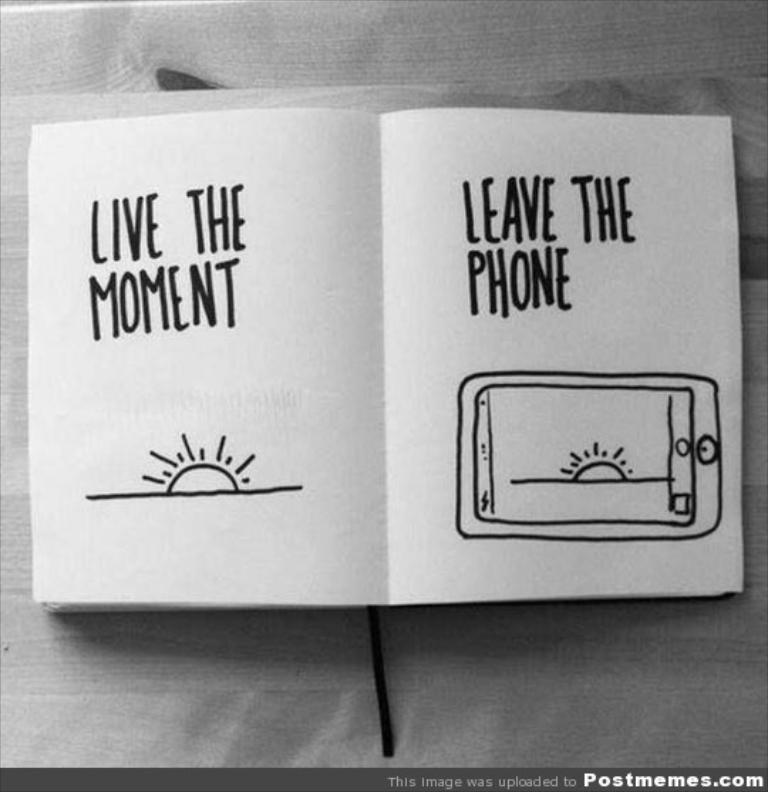What should one do with their phone based on this flyer?
Provide a succinct answer. Unanswerable. What are we supposed to live?
Keep it short and to the point. The moment. 